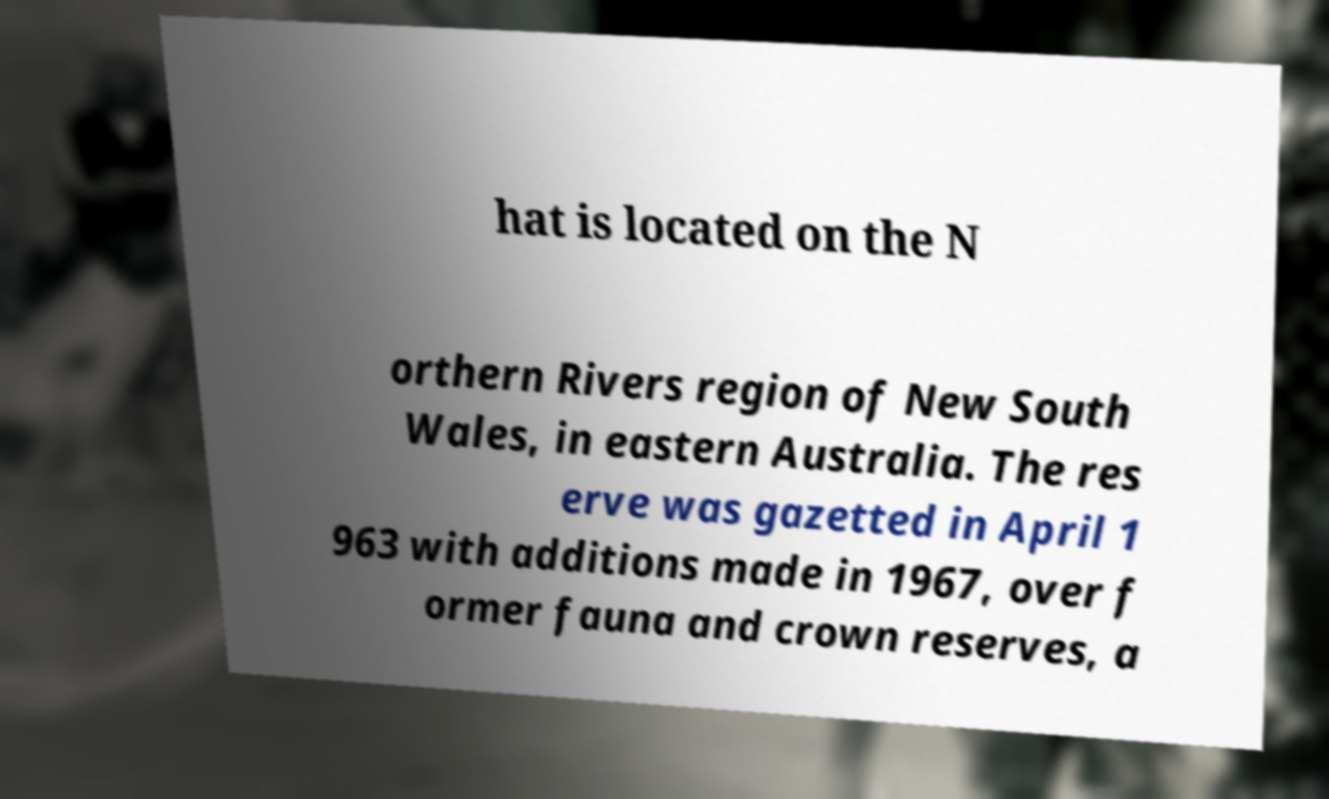I need the written content from this picture converted into text. Can you do that? hat is located on the N orthern Rivers region of New South Wales, in eastern Australia. The res erve was gazetted in April 1 963 with additions made in 1967, over f ormer fauna and crown reserves, a 